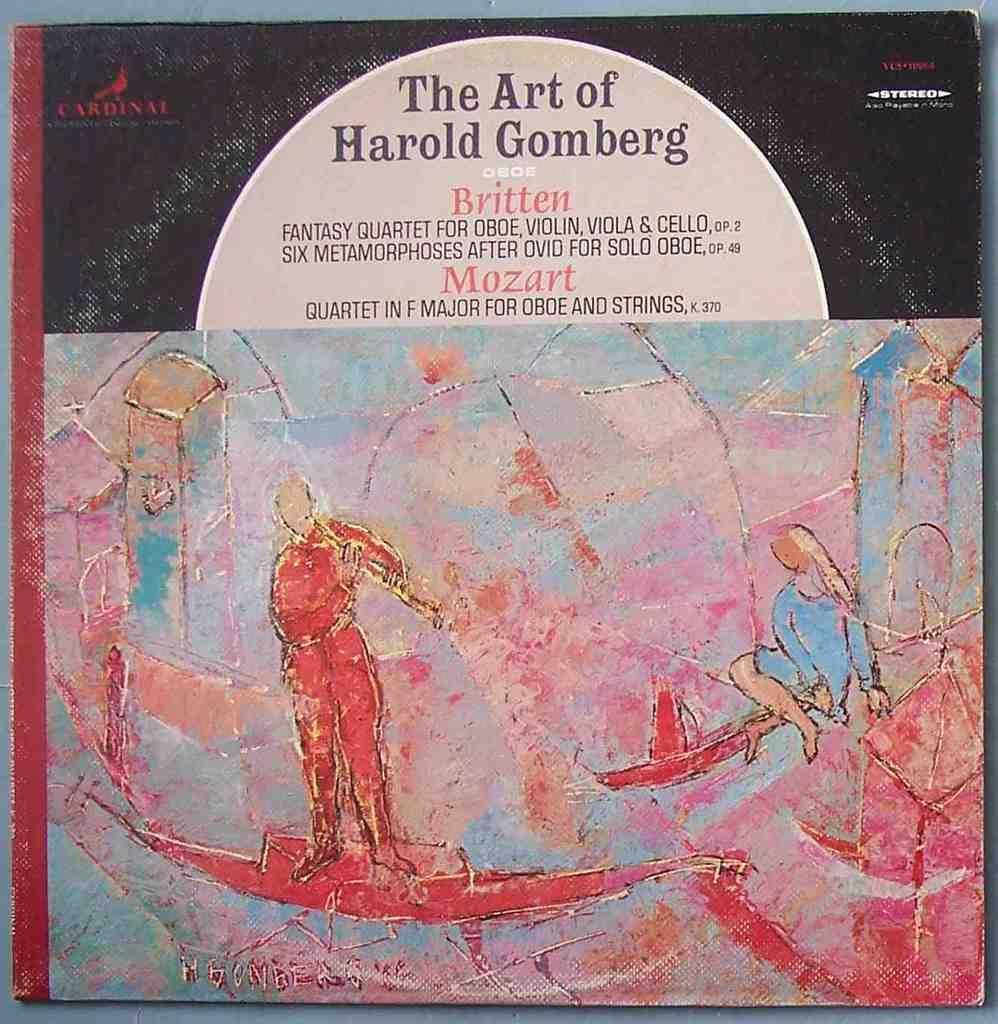Which famous artist is featured on this album?
Your answer should be very brief. Harold gomberg. 